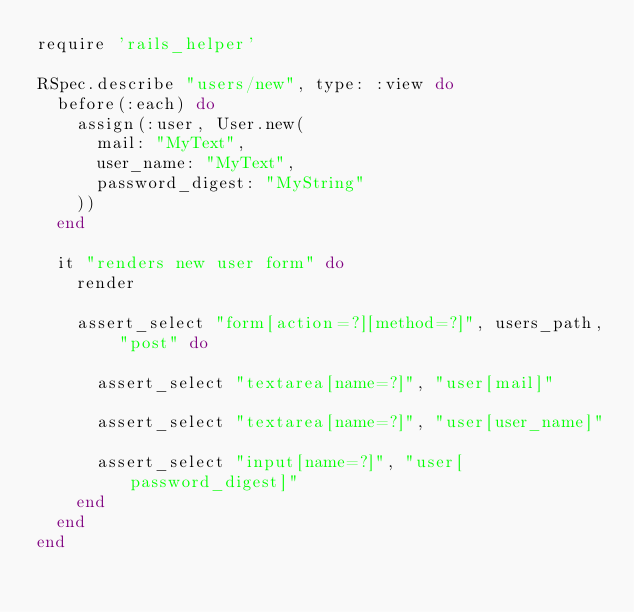<code> <loc_0><loc_0><loc_500><loc_500><_Ruby_>require 'rails_helper'

RSpec.describe "users/new", type: :view do
  before(:each) do
    assign(:user, User.new(
      mail: "MyText",
      user_name: "MyText",
      password_digest: "MyString"
    ))
  end

  it "renders new user form" do
    render

    assert_select "form[action=?][method=?]", users_path, "post" do

      assert_select "textarea[name=?]", "user[mail]"

      assert_select "textarea[name=?]", "user[user_name]"

      assert_select "input[name=?]", "user[password_digest]"
    end
  end
end
</code> 